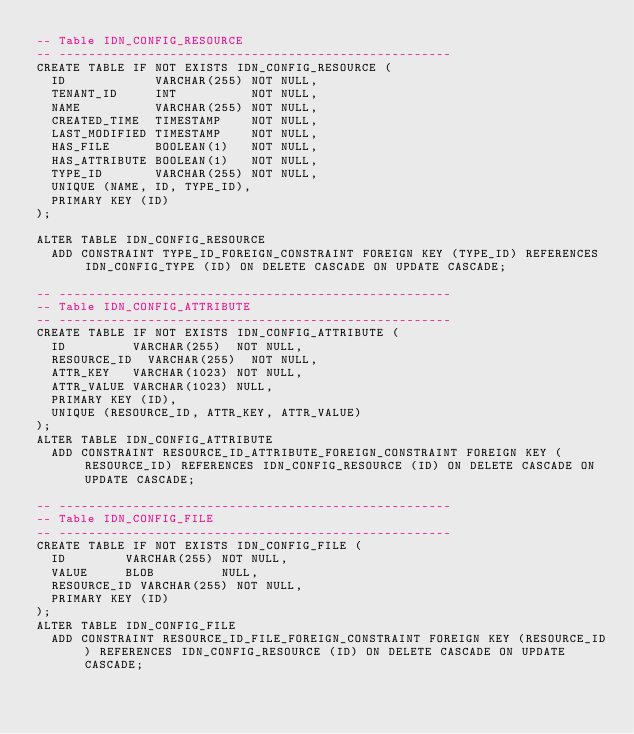Convert code to text. <code><loc_0><loc_0><loc_500><loc_500><_SQL_>-- Table IDN_CONFIG_RESOURCE
-- -----------------------------------------------------
CREATE TABLE IF NOT EXISTS IDN_CONFIG_RESOURCE (
  ID            VARCHAR(255) NOT NULL,
  TENANT_ID     INT          NOT NULL,
  NAME          VARCHAR(255) NOT NULL,
  CREATED_TIME  TIMESTAMP    NOT NULL,
  LAST_MODIFIED TIMESTAMP    NOT NULL,
  HAS_FILE      BOOLEAN(1)   NOT NULL,
  HAS_ATTRIBUTE BOOLEAN(1)   NOT NULL,
  TYPE_ID       VARCHAR(255) NOT NULL,
  UNIQUE (NAME, ID, TYPE_ID),
  PRIMARY KEY (ID)
);

ALTER TABLE IDN_CONFIG_RESOURCE
  ADD CONSTRAINT TYPE_ID_FOREIGN_CONSTRAINT FOREIGN KEY (TYPE_ID) REFERENCES IDN_CONFIG_TYPE (ID) ON DELETE CASCADE ON UPDATE CASCADE;

-- -----------------------------------------------------
-- Table IDN_CONFIG_ATTRIBUTE
-- -----------------------------------------------------
CREATE TABLE IF NOT EXISTS IDN_CONFIG_ATTRIBUTE (
  ID         VARCHAR(255)  NOT NULL,
  RESOURCE_ID  VARCHAR(255)  NOT NULL,
  ATTR_KEY   VARCHAR(1023) NOT NULL,
  ATTR_VALUE VARCHAR(1023) NULL,
  PRIMARY KEY (ID),
  UNIQUE (RESOURCE_ID, ATTR_KEY, ATTR_VALUE)
);
ALTER TABLE IDN_CONFIG_ATTRIBUTE
  ADD CONSTRAINT RESOURCE_ID_ATTRIBUTE_FOREIGN_CONSTRAINT FOREIGN KEY (RESOURCE_ID) REFERENCES IDN_CONFIG_RESOURCE (ID) ON DELETE CASCADE ON UPDATE CASCADE;

-- -----------------------------------------------------
-- Table IDN_CONFIG_FILE
-- -----------------------------------------------------
CREATE TABLE IF NOT EXISTS IDN_CONFIG_FILE (
  ID        VARCHAR(255) NOT NULL,
  VALUE     BLOB         NULL,
  RESOURCE_ID VARCHAR(255) NOT NULL,
  PRIMARY KEY (ID)
);
ALTER TABLE IDN_CONFIG_FILE
  ADD CONSTRAINT RESOURCE_ID_FILE_FOREIGN_CONSTRAINT FOREIGN KEY (RESOURCE_ID) REFERENCES IDN_CONFIG_RESOURCE (ID) ON DELETE CASCADE ON UPDATE CASCADE;</code> 